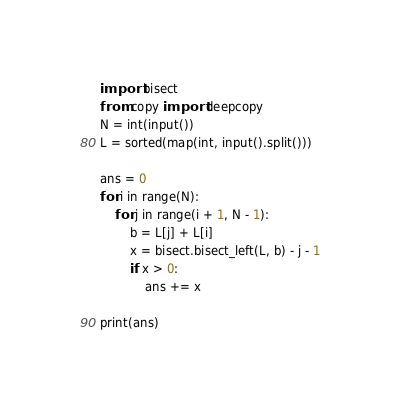<code> <loc_0><loc_0><loc_500><loc_500><_Python_>import bisect
from copy import deepcopy
N = int(input())
L = sorted(map(int, input().split()))

ans = 0
for i in range(N):
    for j in range(i + 1, N - 1):
        b = L[j] + L[i]
        x = bisect.bisect_left(L, b) - j - 1
        if x > 0:
            ans += x

print(ans)
</code> 